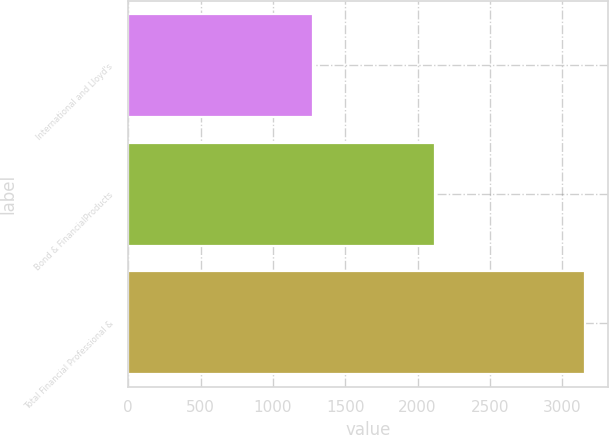<chart> <loc_0><loc_0><loc_500><loc_500><bar_chart><fcel>International and Lloyd's<fcel>Bond & FinancialProducts<fcel>Total Financial Professional &<nl><fcel>1278<fcel>2117<fcel>3159<nl></chart> 